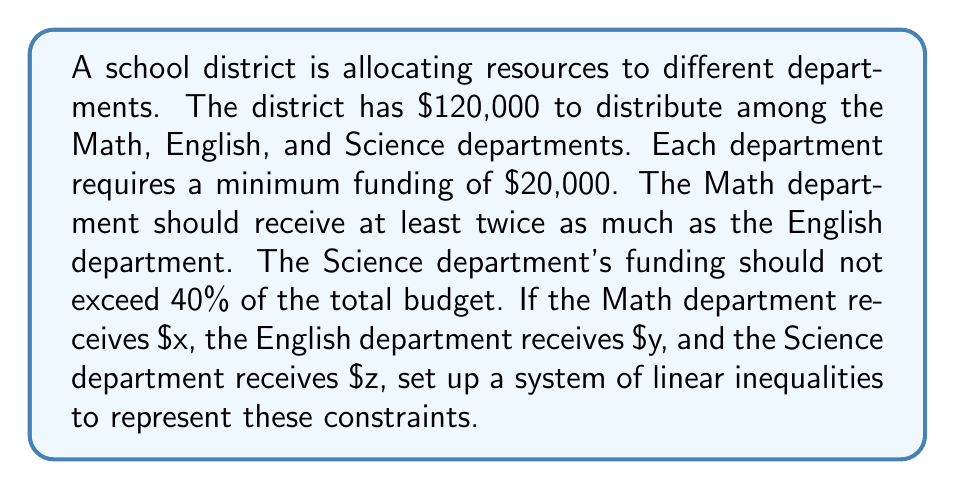What is the answer to this math problem? Let's break this problem down step-by-step:

1) First, we need to define our variables:
   $x$ = funding for Math department
   $y$ = funding for English department
   $z$ = funding for Science department

2) Now, let's translate each constraint into a linear inequality:

   a) Total budget constraint:
      $$x + y + z = 120000$$

   b) Minimum funding for each department:
      $$x \geq 20000$$
      $$y \geq 20000$$
      $$z \geq 20000$$

   c) Math department should receive at least twice as much as English:
      $$x \geq 2y$$

   d) Science department's funding should not exceed 40% of the total budget:
      $$z \leq 0.4(120000) = 48000$$

3) Combining all these inequalities, we get our system:

   $$\begin{cases}
   x + y + z = 120000 \\
   x \geq 20000 \\
   y \geq 20000 \\
   z \geq 20000 \\
   x \geq 2y \\
   z \leq 48000
   \end{cases}$$

This system of linear inequalities represents all the constraints for the resource allocation problem.
Answer: $$\begin{cases}
x + y + z = 120000 \\
x \geq 20000 \\
y \geq 20000 \\
z \geq 20000 \\
x \geq 2y \\
z \leq 48000
\end{cases}$$ 